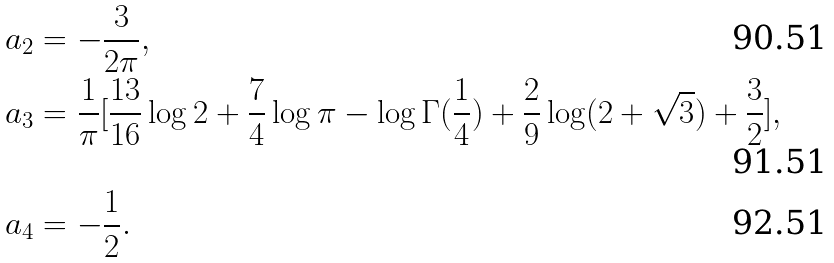<formula> <loc_0><loc_0><loc_500><loc_500>a _ { 2 } & = - \frac { 3 } { 2 \pi } , \\ a _ { 3 } & = \frac { 1 } { \pi } [ \frac { 1 3 } { 1 6 } \log 2 + \frac { 7 } { 4 } \log \pi - \log \Gamma ( \frac { 1 } { 4 } ) + \frac { 2 } { 9 } \log ( 2 + \sqrt { 3 } ) + \frac { 3 } { 2 } ] , \\ a _ { 4 } & = - \frac { 1 } { 2 } .</formula> 